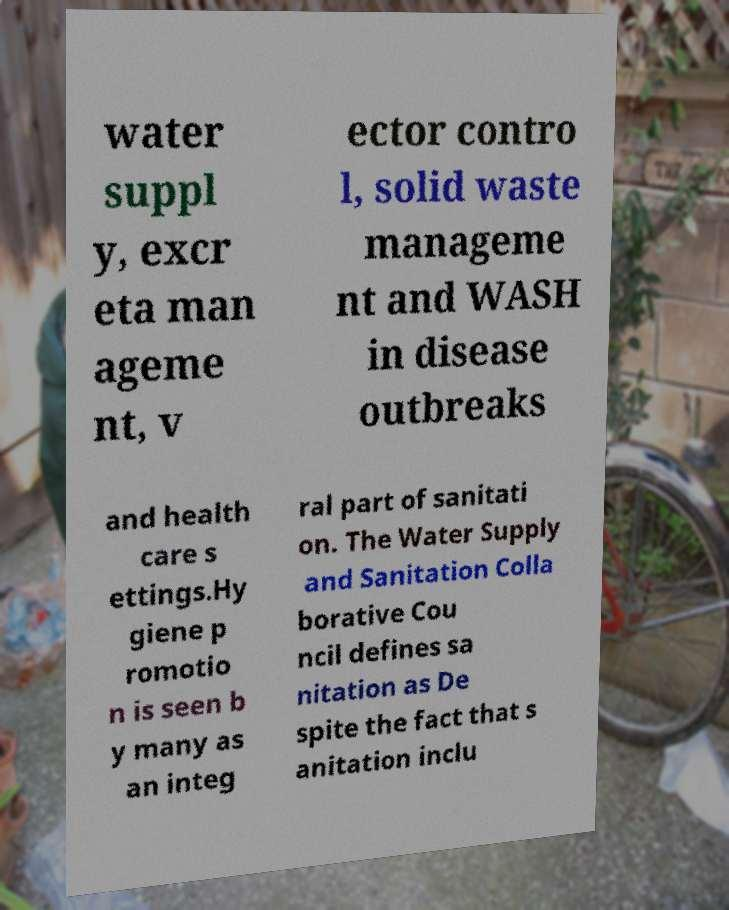Can you read and provide the text displayed in the image?This photo seems to have some interesting text. Can you extract and type it out for me? water suppl y, excr eta man ageme nt, v ector contro l, solid waste manageme nt and WASH in disease outbreaks and health care s ettings.Hy giene p romotio n is seen b y many as an integ ral part of sanitati on. The Water Supply and Sanitation Colla borative Cou ncil defines sa nitation as De spite the fact that s anitation inclu 